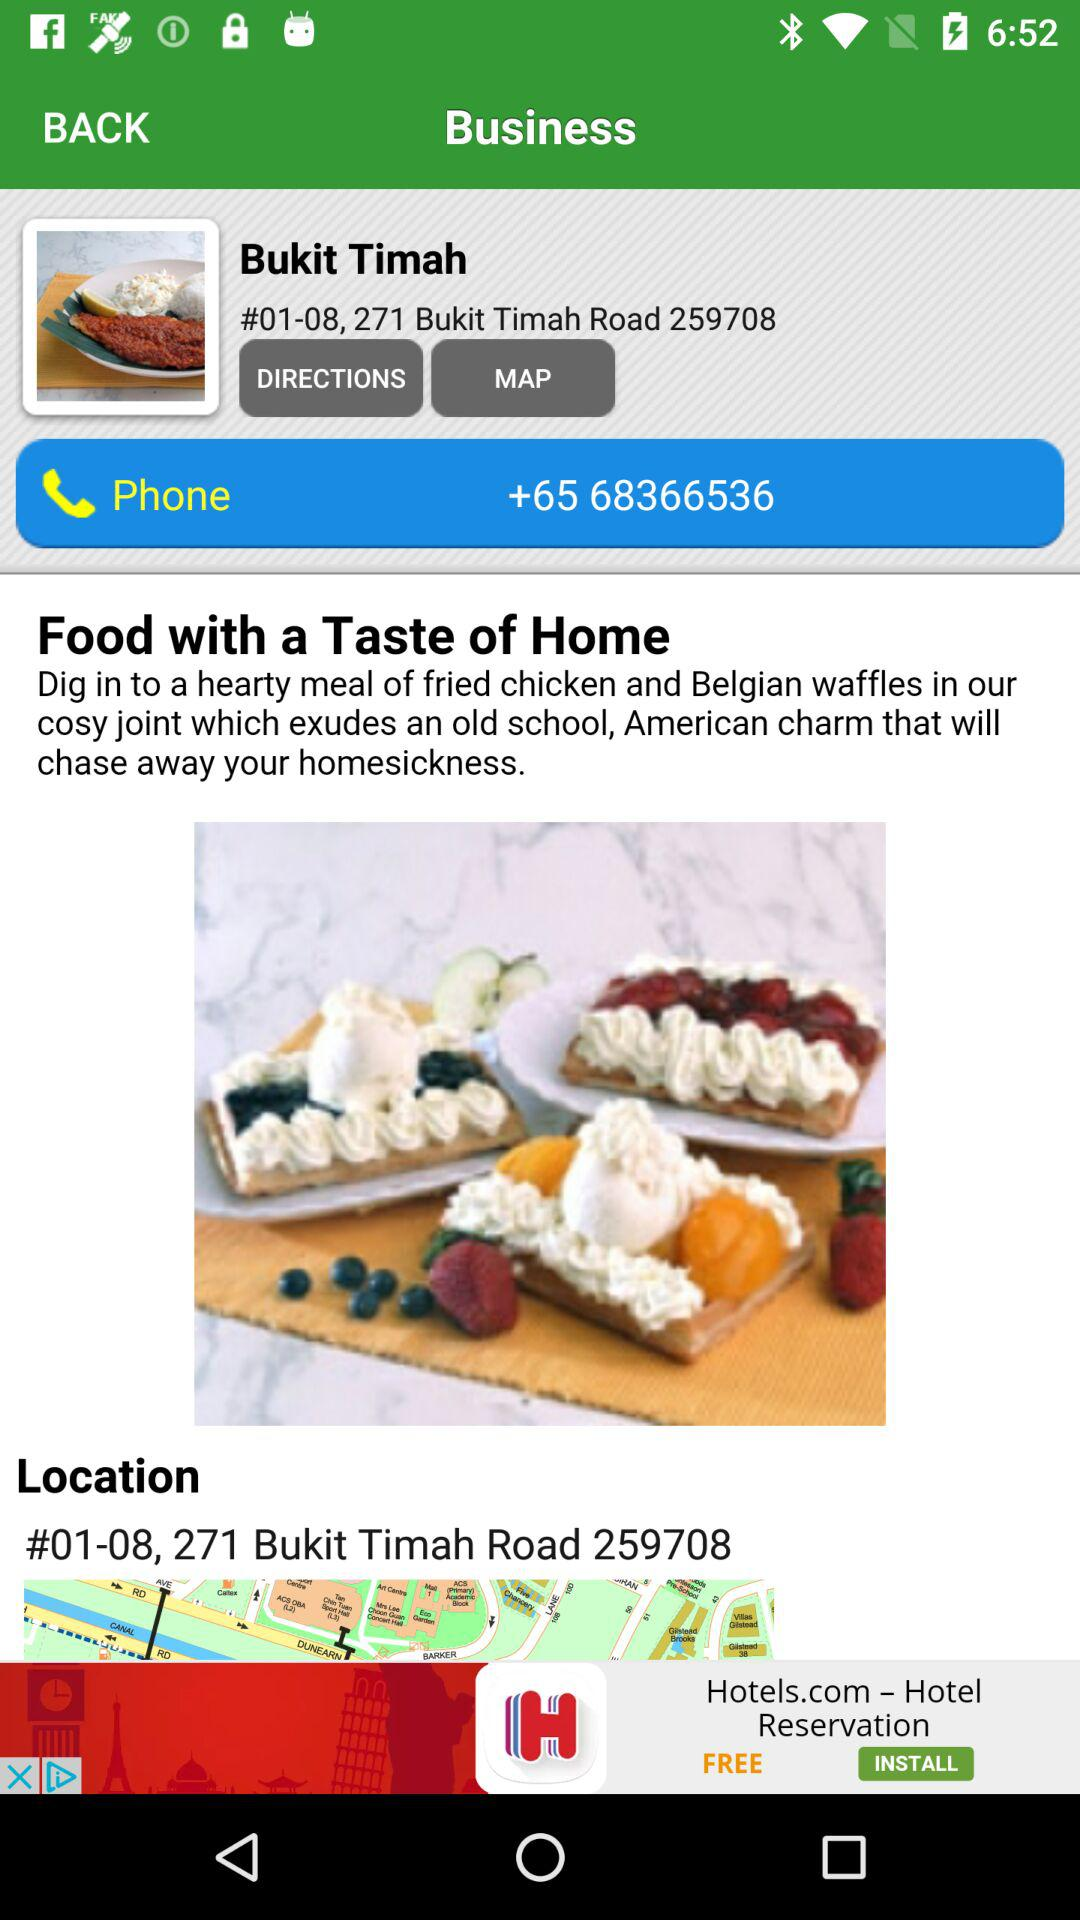What's the location of this restaurant? The location is "#01-08, 271 Bukit Timah 259708". 